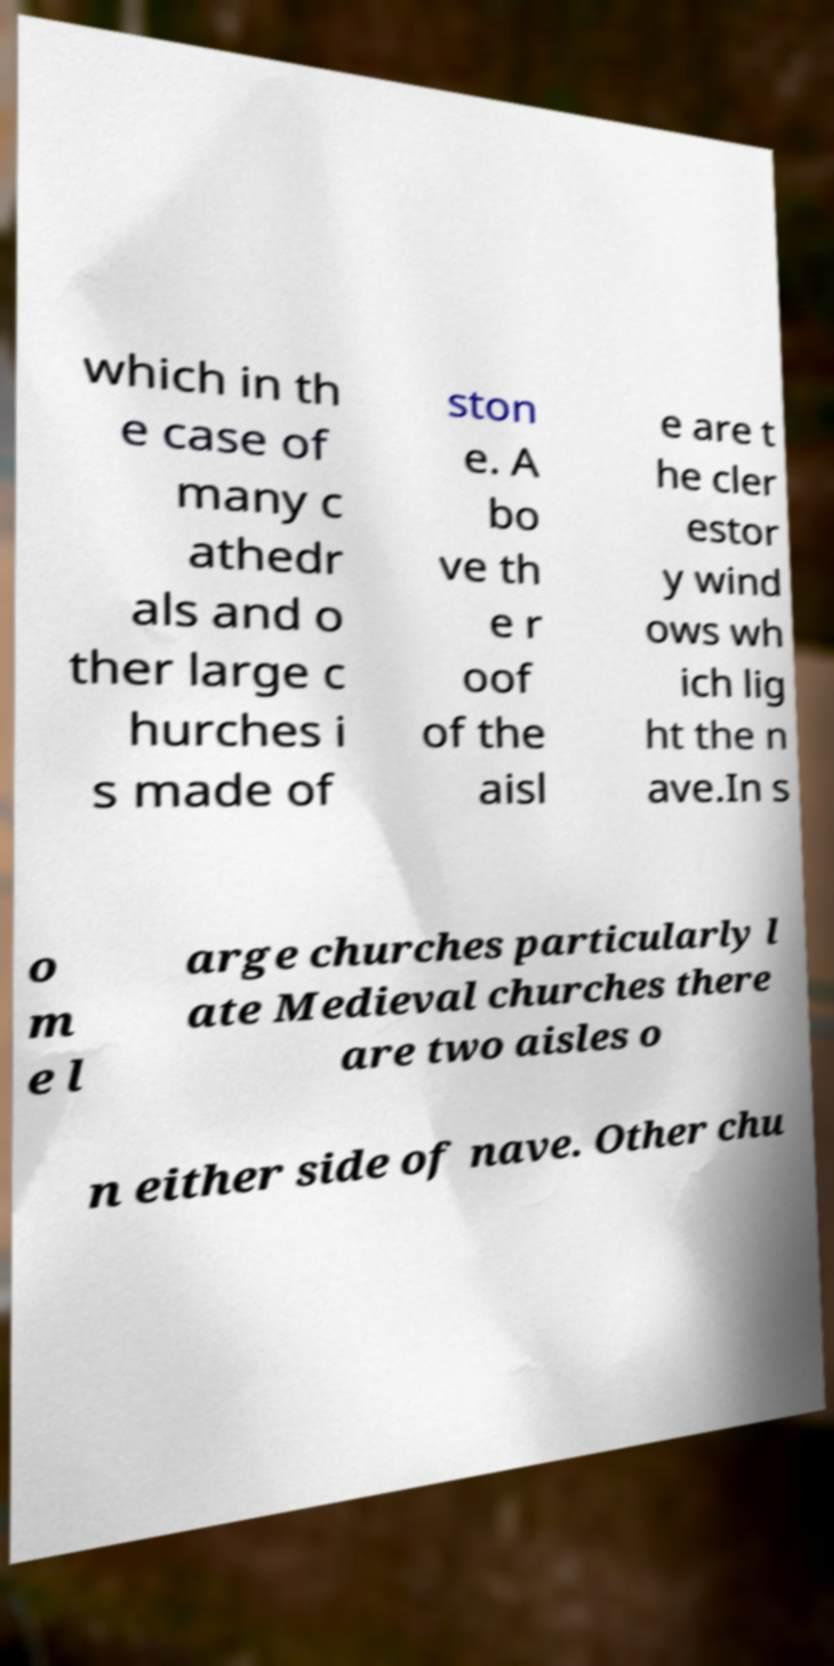Please read and relay the text visible in this image. What does it say? which in th e case of many c athedr als and o ther large c hurches i s made of ston e. A bo ve th e r oof of the aisl e are t he cler estor y wind ows wh ich lig ht the n ave.In s o m e l arge churches particularly l ate Medieval churches there are two aisles o n either side of nave. Other chu 